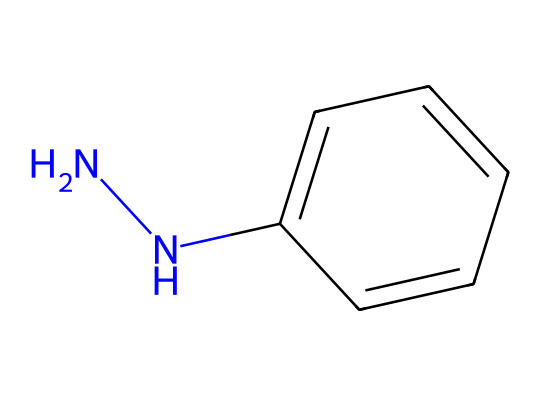What is the molecular formula of phenylhydrazine? The SMILES representation indicates that phenylhydrazine has one nitrogen-nitrogen bond (NN) and a phenyl group (c1ccccc1). Each carbon in the phenyl group contributes to the molecular formula as well. Hence, the molecular formula is C6H8N2.
Answer: C6H8N2 How many carbon atoms are in the structure? By analyzing the SMILES code, there are six carbons in the phenyl ring (c1ccccc1), which indicates the presence of six carbon atoms in total.
Answer: 6 What type of chemical bond connects the two nitrogen atoms? The structure shows that there is a nitrogen-nitrogen single bond represented by 'NN'. This indicates a single covalent bond is present between the nitrogen atoms.
Answer: single bond Why does phenylhydrazine have a high boiling point? The presence of the hydrazine functional group (NN) allows for hydrogen bonding, which is a strong intermolecular force. This significantly raises the boiling point compared to non-hydrogen bonding substances of similar size.
Answer: hydrogen bonding What functional groups are present in phenylhydrazine? The structure shows a hydrazine group (NN) and a phenyl group (C6H5). Both of these groups contribute to the identification of functional groups in phenylhydrazine.
Answer: hydrazine and phenyl Is phenylhydrazine a primary or secondary hydrazine? In the structure, one nitrogen is bonded to two hydrogens and the other nitrogen is bonded to a phenyl group, indicating that it is classified as a primary hydrazine because the hydrazine nitrogen is attached to a carbon group (phenyl).
Answer: primary 